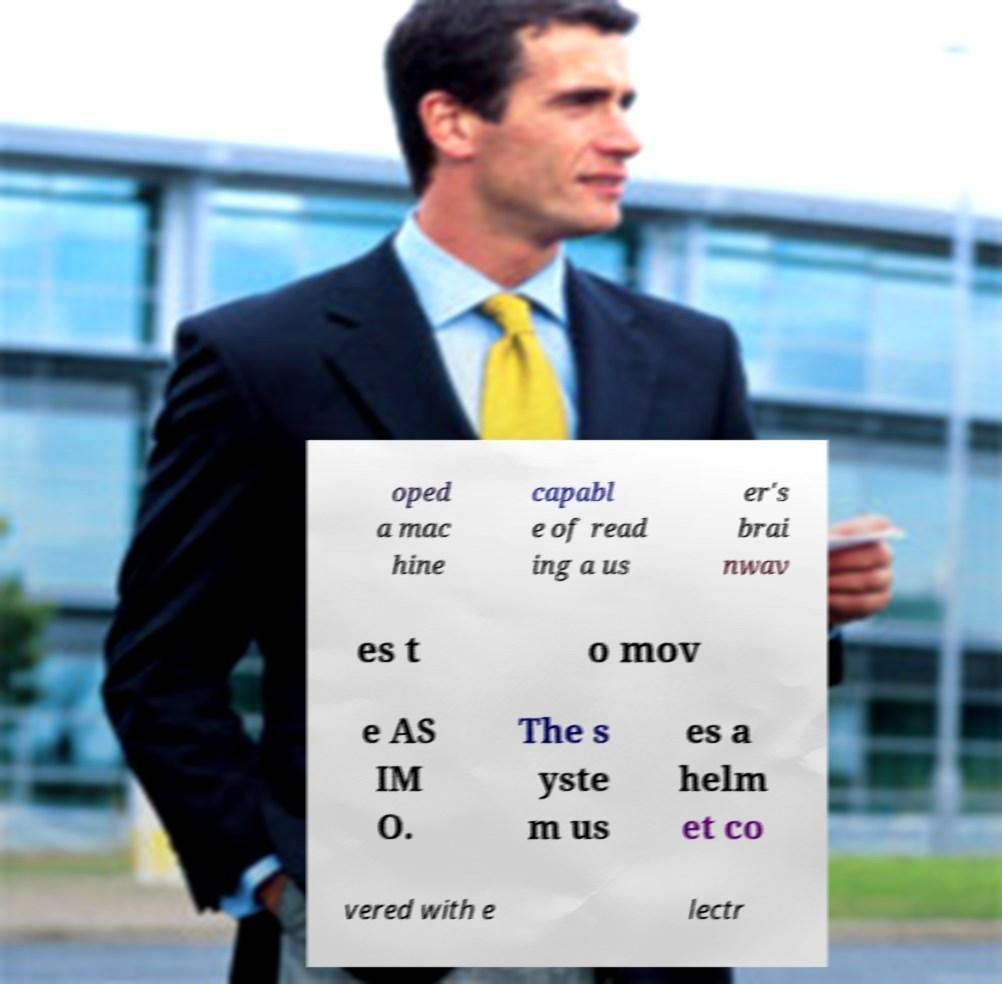For documentation purposes, I need the text within this image transcribed. Could you provide that? oped a mac hine capabl e of read ing a us er's brai nwav es t o mov e AS IM O. The s yste m us es a helm et co vered with e lectr 